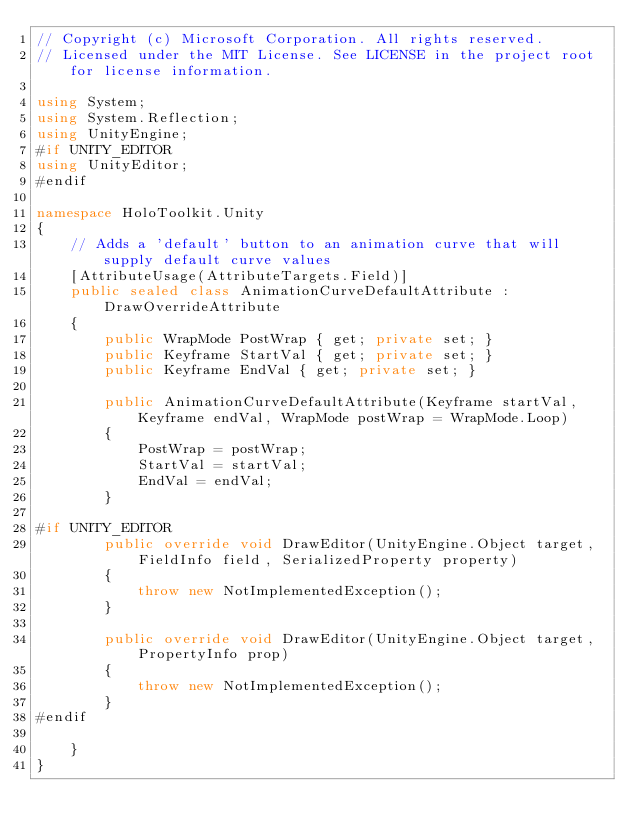Convert code to text. <code><loc_0><loc_0><loc_500><loc_500><_C#_>// Copyright (c) Microsoft Corporation. All rights reserved.
// Licensed under the MIT License. See LICENSE in the project root for license information.

using System;
using System.Reflection;
using UnityEngine;
#if UNITY_EDITOR
using UnityEditor;
#endif

namespace HoloToolkit.Unity
{
    // Adds a 'default' button to an animation curve that will supply default curve values
    [AttributeUsage(AttributeTargets.Field)]
    public sealed class AnimationCurveDefaultAttribute : DrawOverrideAttribute
    {
        public WrapMode PostWrap { get; private set; }
        public Keyframe StartVal { get; private set; }
        public Keyframe EndVal { get; private set; }

        public AnimationCurveDefaultAttribute(Keyframe startVal, Keyframe endVal, WrapMode postWrap = WrapMode.Loop)
        {
            PostWrap = postWrap;
            StartVal = startVal;
            EndVal = endVal;
        }

#if UNITY_EDITOR
        public override void DrawEditor(UnityEngine.Object target, FieldInfo field, SerializedProperty property)
        {
            throw new NotImplementedException();
        }

        public override void DrawEditor(UnityEngine.Object target, PropertyInfo prop)
        {
            throw new NotImplementedException();
        }
#endif

    }
}</code> 